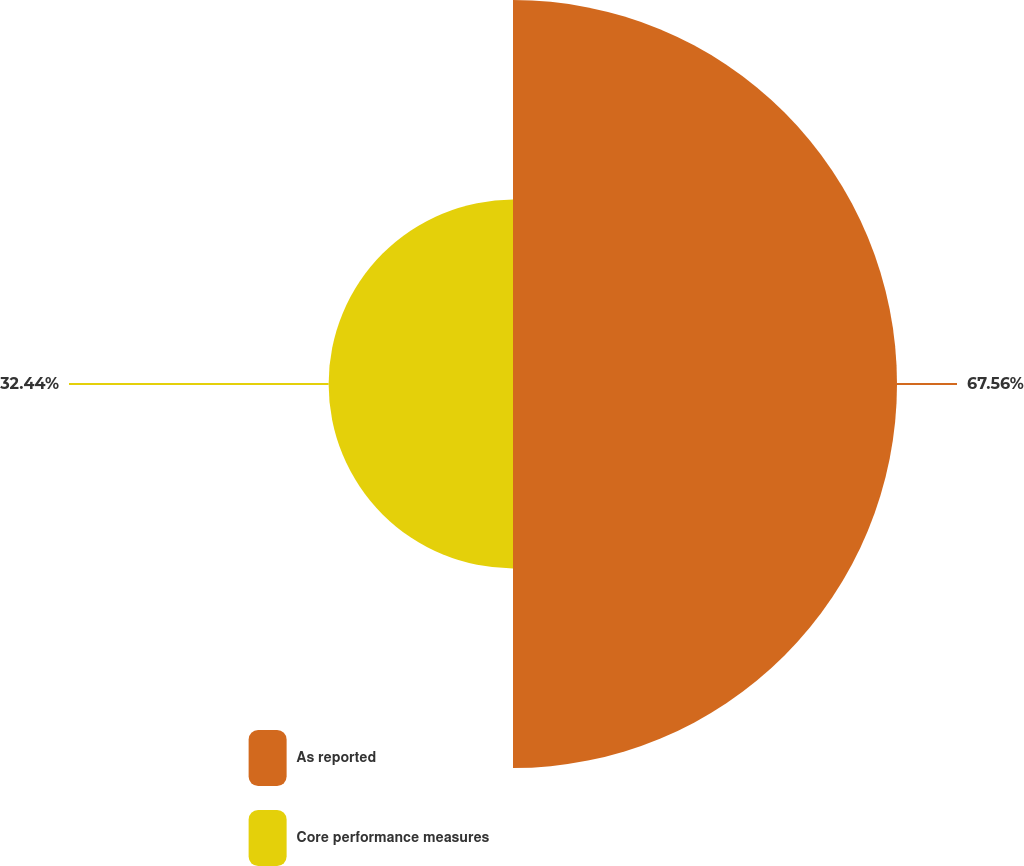Convert chart to OTSL. <chart><loc_0><loc_0><loc_500><loc_500><pie_chart><fcel>As reported<fcel>Core performance measures<nl><fcel>67.56%<fcel>32.44%<nl></chart> 